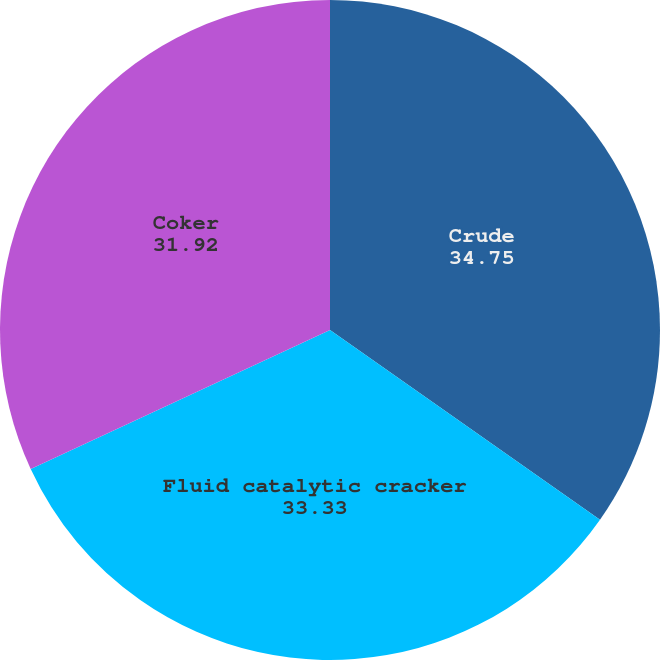<chart> <loc_0><loc_0><loc_500><loc_500><pie_chart><fcel>Crude<fcel>Fluid catalytic cracker<fcel>Coker<nl><fcel>34.75%<fcel>33.33%<fcel>31.92%<nl></chart> 